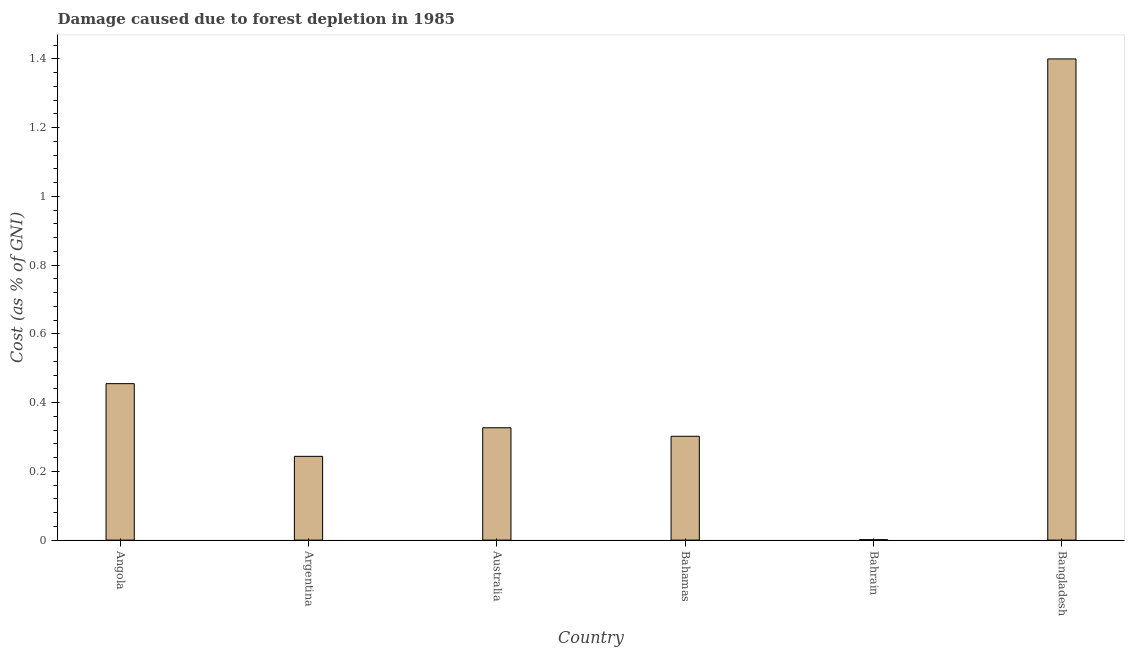Does the graph contain any zero values?
Offer a terse response. No. Does the graph contain grids?
Your answer should be compact. No. What is the title of the graph?
Offer a terse response. Damage caused due to forest depletion in 1985. What is the label or title of the X-axis?
Provide a succinct answer. Country. What is the label or title of the Y-axis?
Keep it short and to the point. Cost (as % of GNI). What is the damage caused due to forest depletion in Argentina?
Provide a succinct answer. 0.24. Across all countries, what is the maximum damage caused due to forest depletion?
Keep it short and to the point. 1.4. Across all countries, what is the minimum damage caused due to forest depletion?
Your answer should be compact. 0. In which country was the damage caused due to forest depletion maximum?
Keep it short and to the point. Bangladesh. In which country was the damage caused due to forest depletion minimum?
Offer a very short reply. Bahrain. What is the sum of the damage caused due to forest depletion?
Offer a very short reply. 2.73. What is the difference between the damage caused due to forest depletion in Argentina and Bahamas?
Give a very brief answer. -0.06. What is the average damage caused due to forest depletion per country?
Your answer should be compact. 0.46. What is the median damage caused due to forest depletion?
Keep it short and to the point. 0.31. In how many countries, is the damage caused due to forest depletion greater than 1.08 %?
Provide a short and direct response. 1. What is the ratio of the damage caused due to forest depletion in Bahamas to that in Bahrain?
Your response must be concise. 266.5. Is the difference between the damage caused due to forest depletion in Bahrain and Bangladesh greater than the difference between any two countries?
Offer a very short reply. Yes. What is the difference between the highest and the second highest damage caused due to forest depletion?
Ensure brevity in your answer.  0.94. What is the difference between the highest and the lowest damage caused due to forest depletion?
Your answer should be very brief. 1.4. How many bars are there?
Your response must be concise. 6. Are all the bars in the graph horizontal?
Give a very brief answer. No. How many countries are there in the graph?
Make the answer very short. 6. What is the Cost (as % of GNI) in Angola?
Offer a very short reply. 0.46. What is the Cost (as % of GNI) of Argentina?
Offer a terse response. 0.24. What is the Cost (as % of GNI) in Australia?
Offer a very short reply. 0.33. What is the Cost (as % of GNI) of Bahamas?
Make the answer very short. 0.3. What is the Cost (as % of GNI) in Bahrain?
Your answer should be compact. 0. What is the Cost (as % of GNI) of Bangladesh?
Give a very brief answer. 1.4. What is the difference between the Cost (as % of GNI) in Angola and Argentina?
Offer a very short reply. 0.21. What is the difference between the Cost (as % of GNI) in Angola and Australia?
Keep it short and to the point. 0.13. What is the difference between the Cost (as % of GNI) in Angola and Bahamas?
Make the answer very short. 0.15. What is the difference between the Cost (as % of GNI) in Angola and Bahrain?
Make the answer very short. 0.45. What is the difference between the Cost (as % of GNI) in Angola and Bangladesh?
Your answer should be compact. -0.94. What is the difference between the Cost (as % of GNI) in Argentina and Australia?
Keep it short and to the point. -0.08. What is the difference between the Cost (as % of GNI) in Argentina and Bahamas?
Ensure brevity in your answer.  -0.06. What is the difference between the Cost (as % of GNI) in Argentina and Bahrain?
Provide a short and direct response. 0.24. What is the difference between the Cost (as % of GNI) in Argentina and Bangladesh?
Provide a succinct answer. -1.16. What is the difference between the Cost (as % of GNI) in Australia and Bahamas?
Your answer should be very brief. 0.02. What is the difference between the Cost (as % of GNI) in Australia and Bahrain?
Ensure brevity in your answer.  0.33. What is the difference between the Cost (as % of GNI) in Australia and Bangladesh?
Your response must be concise. -1.07. What is the difference between the Cost (as % of GNI) in Bahamas and Bahrain?
Offer a terse response. 0.3. What is the difference between the Cost (as % of GNI) in Bahamas and Bangladesh?
Ensure brevity in your answer.  -1.1. What is the difference between the Cost (as % of GNI) in Bahrain and Bangladesh?
Offer a very short reply. -1.4. What is the ratio of the Cost (as % of GNI) in Angola to that in Argentina?
Make the answer very short. 1.87. What is the ratio of the Cost (as % of GNI) in Angola to that in Australia?
Ensure brevity in your answer.  1.39. What is the ratio of the Cost (as % of GNI) in Angola to that in Bahamas?
Ensure brevity in your answer.  1.51. What is the ratio of the Cost (as % of GNI) in Angola to that in Bahrain?
Offer a very short reply. 401.52. What is the ratio of the Cost (as % of GNI) in Angola to that in Bangladesh?
Your response must be concise. 0.33. What is the ratio of the Cost (as % of GNI) in Argentina to that in Australia?
Offer a terse response. 0.75. What is the ratio of the Cost (as % of GNI) in Argentina to that in Bahamas?
Give a very brief answer. 0.81. What is the ratio of the Cost (as % of GNI) in Argentina to that in Bahrain?
Ensure brevity in your answer.  214.94. What is the ratio of the Cost (as % of GNI) in Argentina to that in Bangladesh?
Ensure brevity in your answer.  0.17. What is the ratio of the Cost (as % of GNI) in Australia to that in Bahamas?
Make the answer very short. 1.08. What is the ratio of the Cost (as % of GNI) in Australia to that in Bahrain?
Keep it short and to the point. 288.3. What is the ratio of the Cost (as % of GNI) in Australia to that in Bangladesh?
Your answer should be very brief. 0.23. What is the ratio of the Cost (as % of GNI) in Bahamas to that in Bahrain?
Ensure brevity in your answer.  266.5. What is the ratio of the Cost (as % of GNI) in Bahamas to that in Bangladesh?
Offer a terse response. 0.22. 